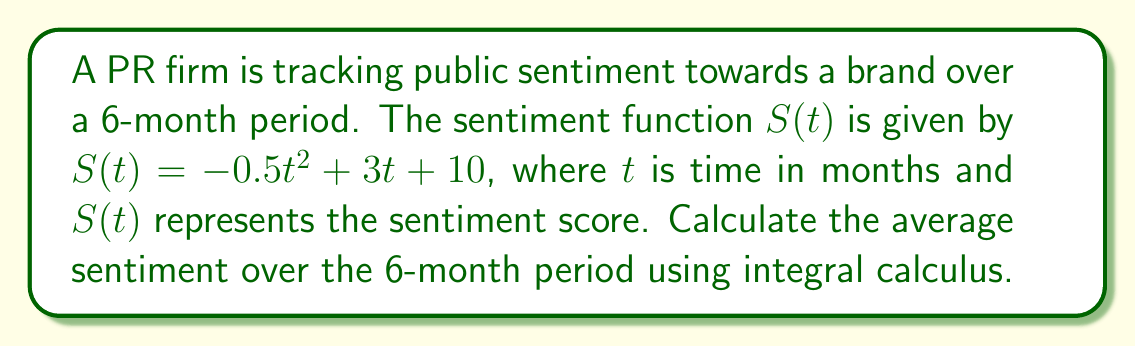Solve this math problem. To find the average sentiment over the 6-month period, we need to:

1. Calculate the area under the curve (total sentiment) using integration
2. Divide the result by the time period (6 months)

Step 1: Integrate the sentiment function from 0 to 6 months

$$\int_0^6 S(t) dt = \int_0^6 (-0.5t^2 + 3t + 10) dt$$

$$= [-\frac{1}{6}t^3 + \frac{3}{2}t^2 + 10t]_0^6$$

$$= [-\frac{1}{6}(6^3) + \frac{3}{2}(6^2) + 10(6)] - [-\frac{1}{6}(0^3) + \frac{3}{2}(0^2) + 10(0)]$$

$$= [-36 + 54 + 60] - [0]$$

$$= 78$$

Step 2: Divide the total sentiment by the time period

Average Sentiment = $\frac{\text{Total Sentiment}}{\text{Time Period}} = \frac{78}{6} = 13$

Therefore, the average sentiment over the 6-month period is 13.
Answer: 13 